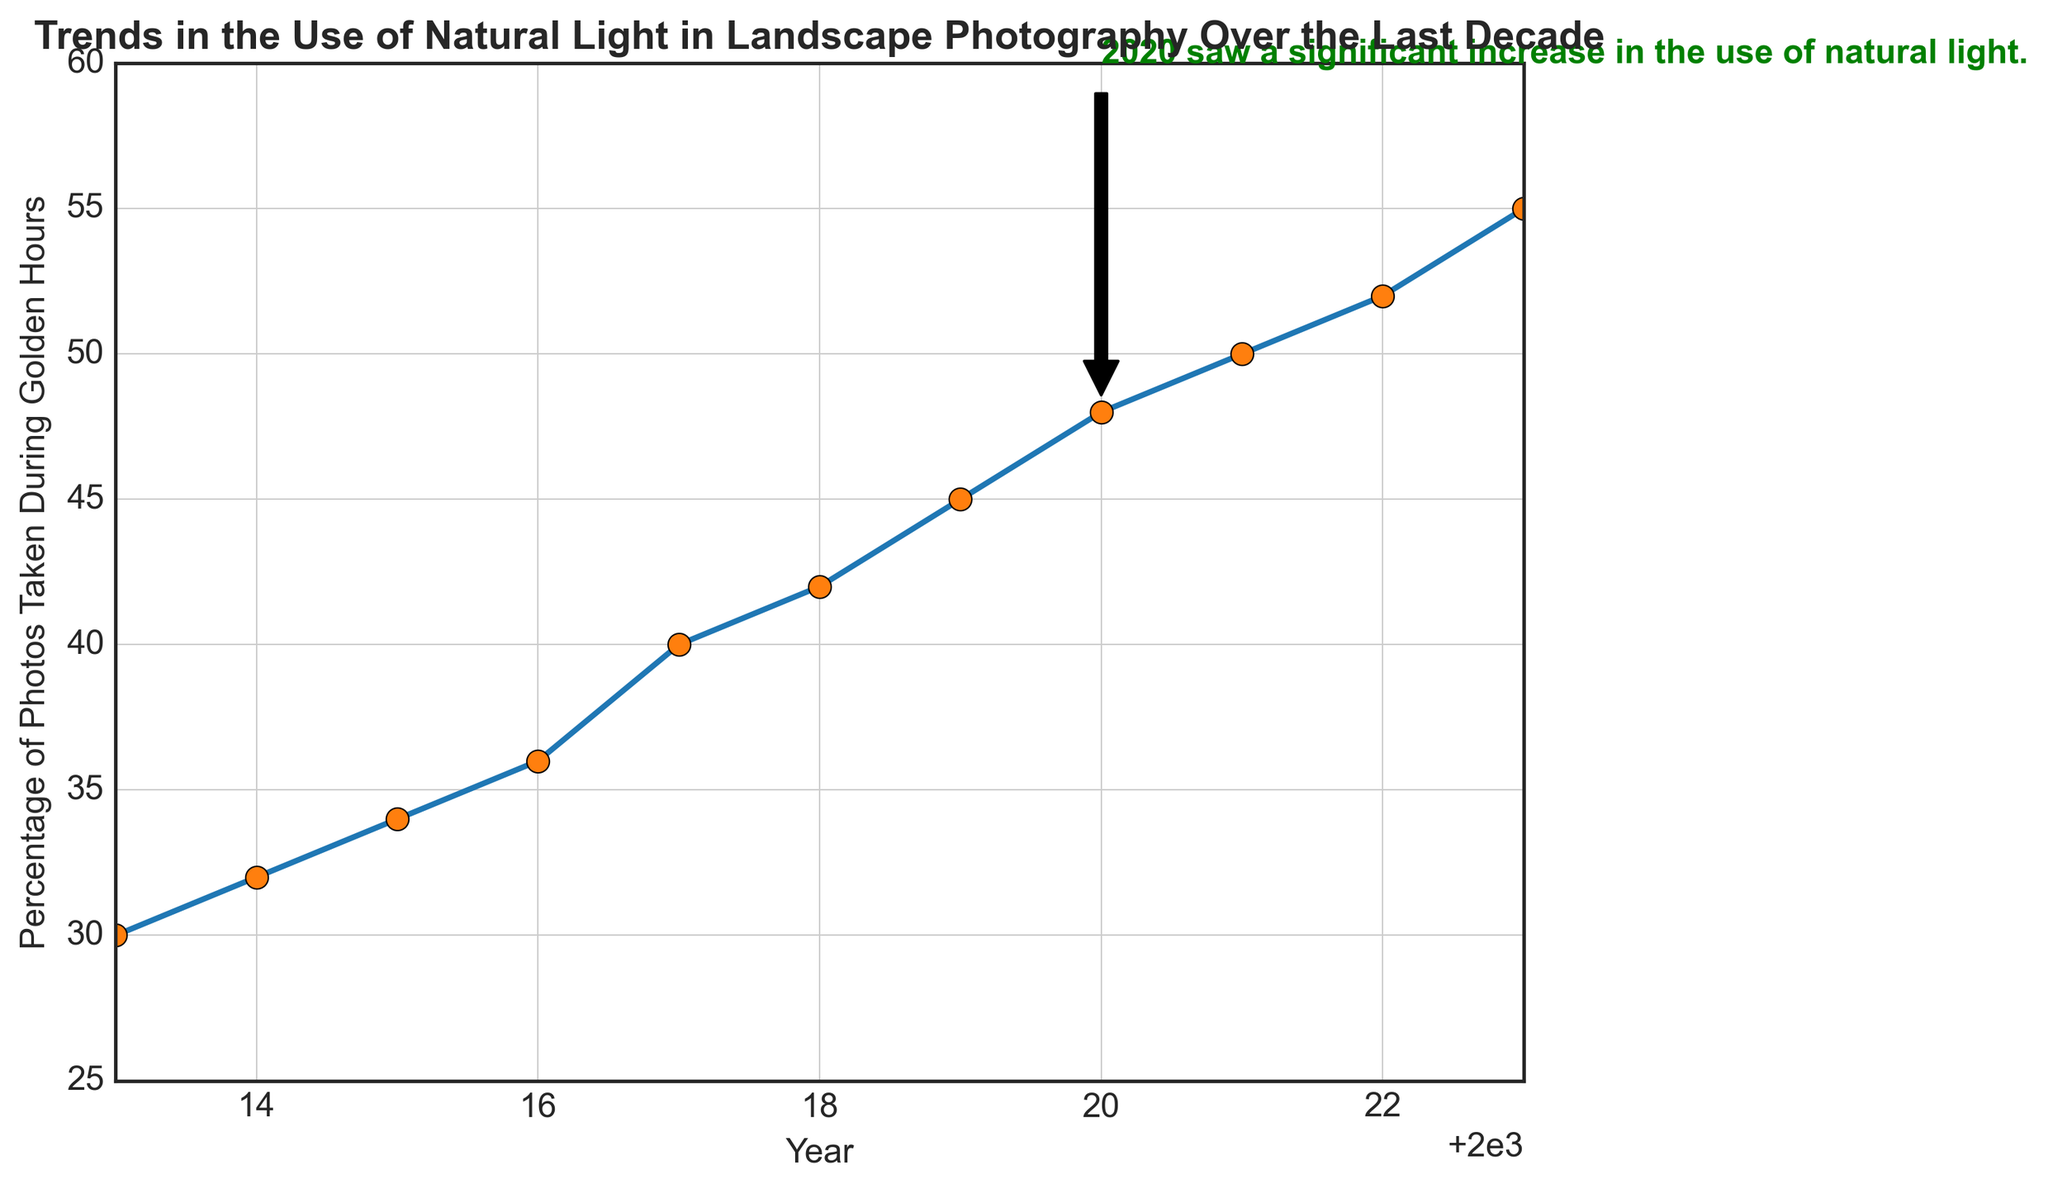What is the trend in the percentage of photos taken during golden hours from 2013 to 2023? The trend shows a steady increase, with the percentage rising from 30% in 2013 to 55% in 2023. This upward slope indicates a growing preference for using natural light during golden hours in landscape photography over the decade.
Answer: Steady increase Which year marks the highest percentage of photos taken during golden hours? The highest percentage is noted in 2023 when it reaches 55%. This can be identified as the data point at the end of the figure.
Answer: 2023 What was the percentage increase in the use of natural light during golden hours from 2018 to 2023? To calculate the increase, subtract the percentage in 2018 (42%) from that in 2023 (55%). Thus, the percentage increase is 55% - 42% = 13%.
Answer: 13% How does the percentage of photos taken during golden hours in 2020 compare to that in 2019? In 2020, the percentage was 48% and in 2019 it was 45%. By subtracting the two, 48% - 45%, we find that there was a 3% increase in 2020 compared to 2019.
Answer: 3% increase Around which year was there a noticeable annotation highlighting a significant increase in the use of natural light? The annotation on the figure points to the year 2020, highlighting that there was a significant increase in the use of natural light.
Answer: 2020 Between which two consecutive years was the largest increase in percentage observed? The largest increase between two consecutive years can be found by calculating the difference year by year. The most significant change was between 2019 (45%) and 2020 (48%), with a 3% increase. Other differences are smaller.
Answer: 2019 to 2020 How does the percentage value of photos taken during golden hours in 2021 compare with the initial year 2013? In 2021, the percentage was 50%, while in 2013 it was 30%. Thus, the difference is 50% - 30% = 20%, indicating that the value in 2021 is 20% higher than in 2013.
Answer: 20% higher From 2015 to 2017, what is the average percentage of photos taken during golden hours? To find the average, sum the values from 2015 (34%), 2016 (36%), and 2017 (40%), then divide by 3. (34 + 36 + 40) / 3 = 110 / 3 = 36.67%.
Answer: 36.67% Describe the visual attribute of the annotation text on the figure. The annotation text is written in green color, bold font, and points to the year 2020 with an arrow starting from 2020's data point (48%) and extends to a text point labeled above the plot lines.
Answer: Green, bold, with an arrow What general pattern can be observed in the percentage values over the decade, and what might this indicate about trends in landscape photography? A general upward pattern in the percentage values suggests a growing appreciation for the quality of natural light during golden hours among landscape photographers. The period-specific highs indicate a shifted focus towards optimal lighting conditions for stunning visuals.
Answer: Upward pattern 